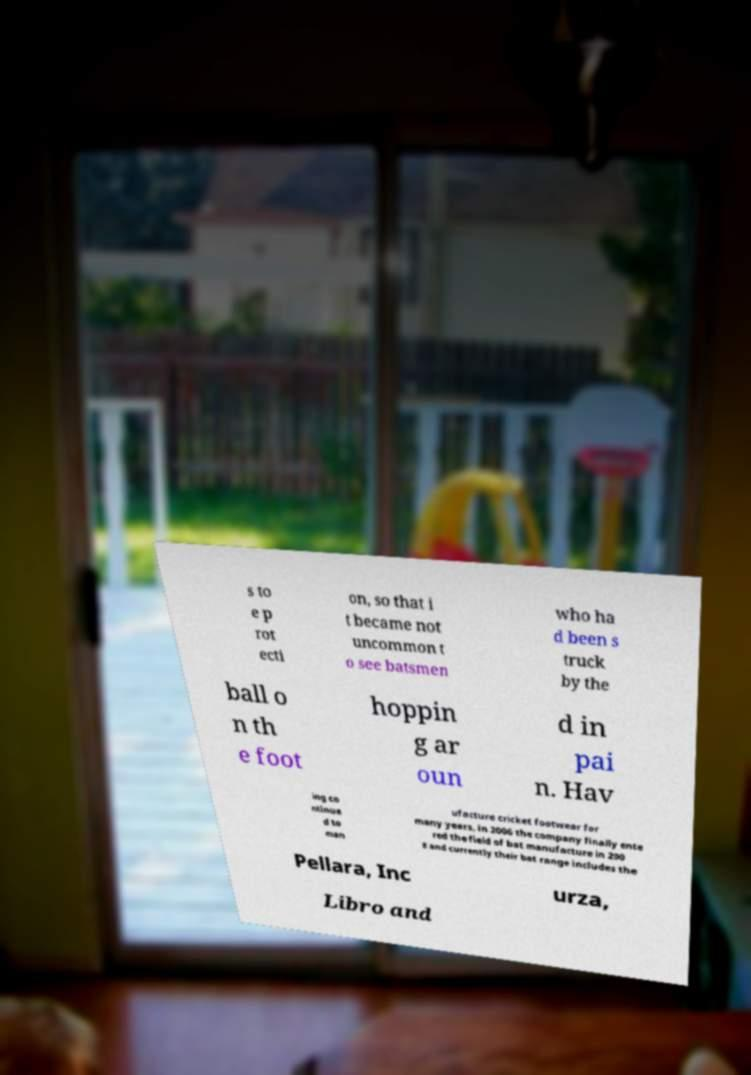There's text embedded in this image that I need extracted. Can you transcribe it verbatim? s to e p rot ecti on, so that i t became not uncommon t o see batsmen who ha d been s truck by the ball o n th e foot hoppin g ar oun d in pai n. Hav ing co ntinue d to man ufacture cricket footwear for many years, in 2006 the company finally ente red the field of bat manufacture in 200 8 and currently their bat range includes the Pellara, Inc urza, Libro and 